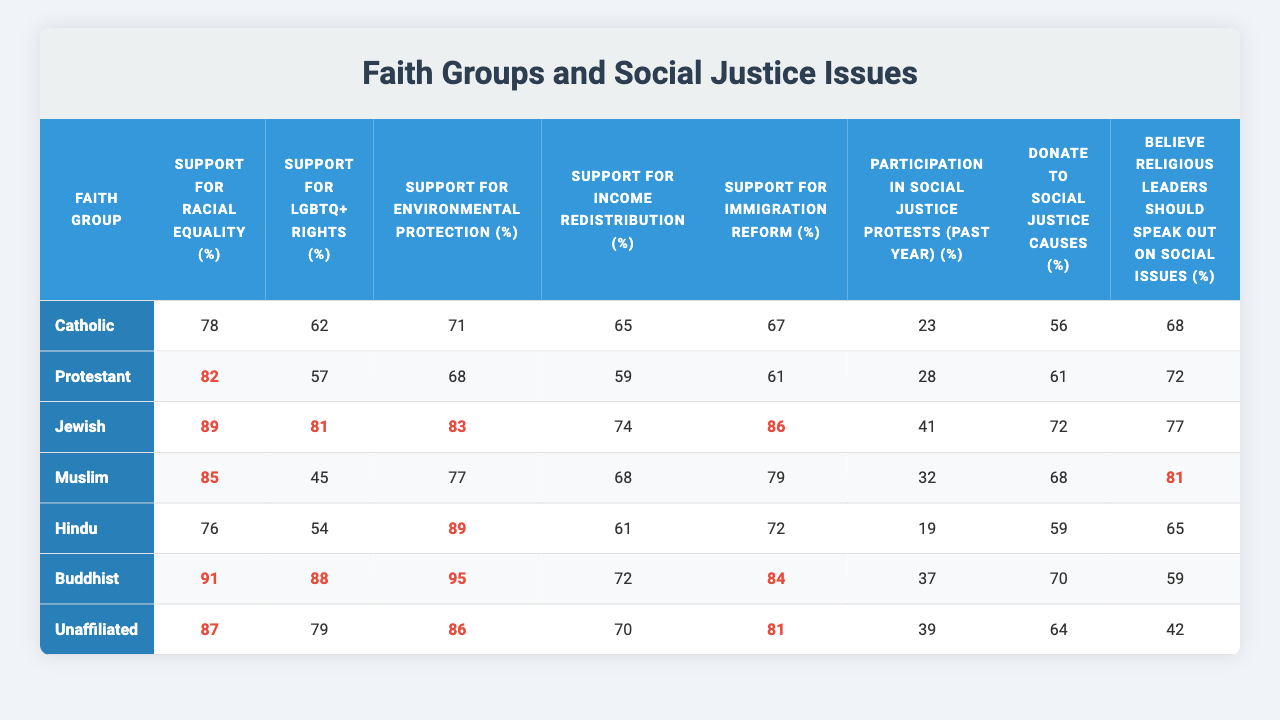What is the support for LGBTQ+ rights among Buddhists? The table shows that the support for LGBTQ+ rights among Buddhists is 88%.
Answer: 88% Which faith group has the highest support for racial equality? The table indicates that Jewish individuals have the highest support for racial equality at 89%.
Answer: Jewish What percentage of Protestants believe religious leaders should speak out on social issues? According to the table, 72% of Protestants believe religious leaders should speak out on social issues.
Answer: 72% Which faith group has the lowest reported participation in social justice protests in the past year? The table lists Hindus as having the lowest percentage of participation in social justice protests at 19%.
Answer: Hindu What is the average support for environmental protection across all faith groups? By summing the support values (71 + 68 + 83 + 77 + 89 + 95 + 86) = 569 and dividing by the number of groups (7), the average support is 569/7 ≈ 81.29%.
Answer: 81.29% Is the support for income redistribution among Muslims higher than that among Catholics? The table shows that the support for income redistribution among Muslims is 68%, while among Catholics it is 65%, confirming that Muslims have higher support.
Answer: Yes What is the difference in support for immigration reform between Protestants and Jews? Protestants show 61% support for immigration reform and Jews show 86%, so the difference is 86% - 61% = 25%.
Answer: 25% Which group has the highest belief that religious leaders should speak out on social issues and what is the percentage? The table reveals that Muslims have the highest belief at 81%.
Answer: 81% What is the total percentage of Catholics that support both racial equality and environmental protection? Catholics support racial equality at 78% and environmental protection at 71%, so the total is 78% + 71% = 149%.
Answer: 149% How do the support levels for LGBTQ+ rights compare between the unaffiliated and Catholics? The unaffiliated have 79% support for LGBTQ+ rights, while Catholics have 62%, indicating the unaffiliated group has higher support.
Answer: Unaffiliated has higher support 